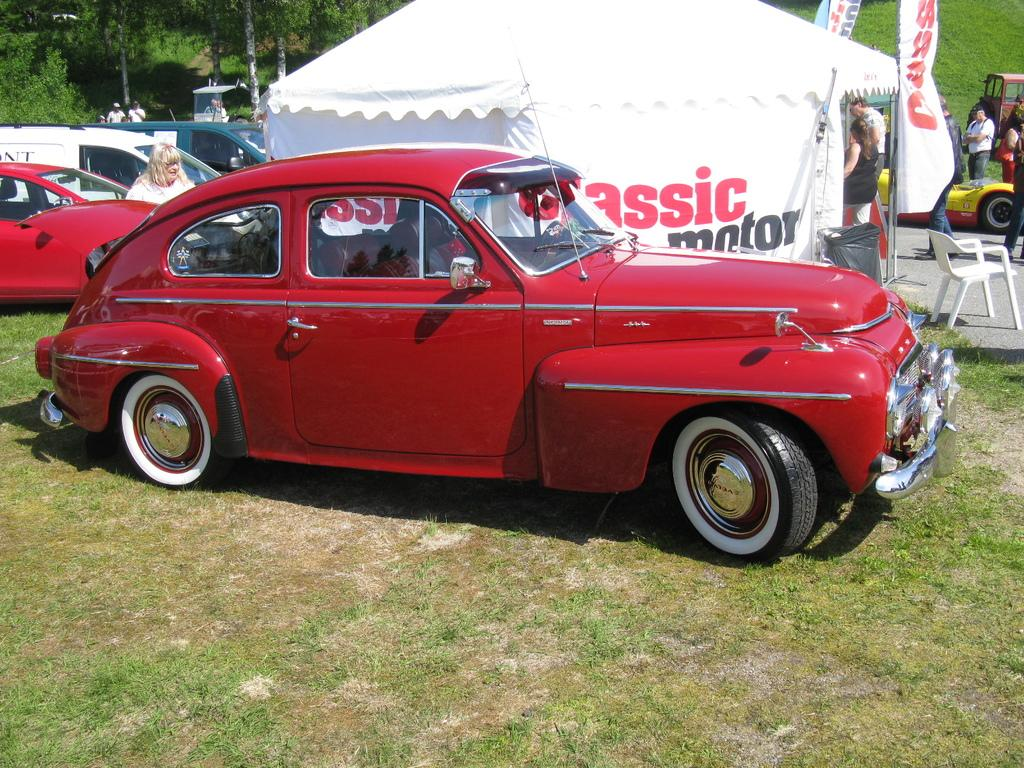What can be seen on the ground in the image? There are cars parked on the ground in the image. What type of surface is the ground covered with? The ground is covered with grass. Are there any people present in the image? Yes, there are people standing in the image. What can be seen in the background of the image? There is a tent visible in the background of the image. Where is the pail located in the image? There is no pail present in the image. What type of vest is being worn by the people in the image? There is no information about the type of vest being worn by the people in the image, as it is not mentioned in the provided facts. Can you see an airplane in the image? No, there is no airplane present in the image. 